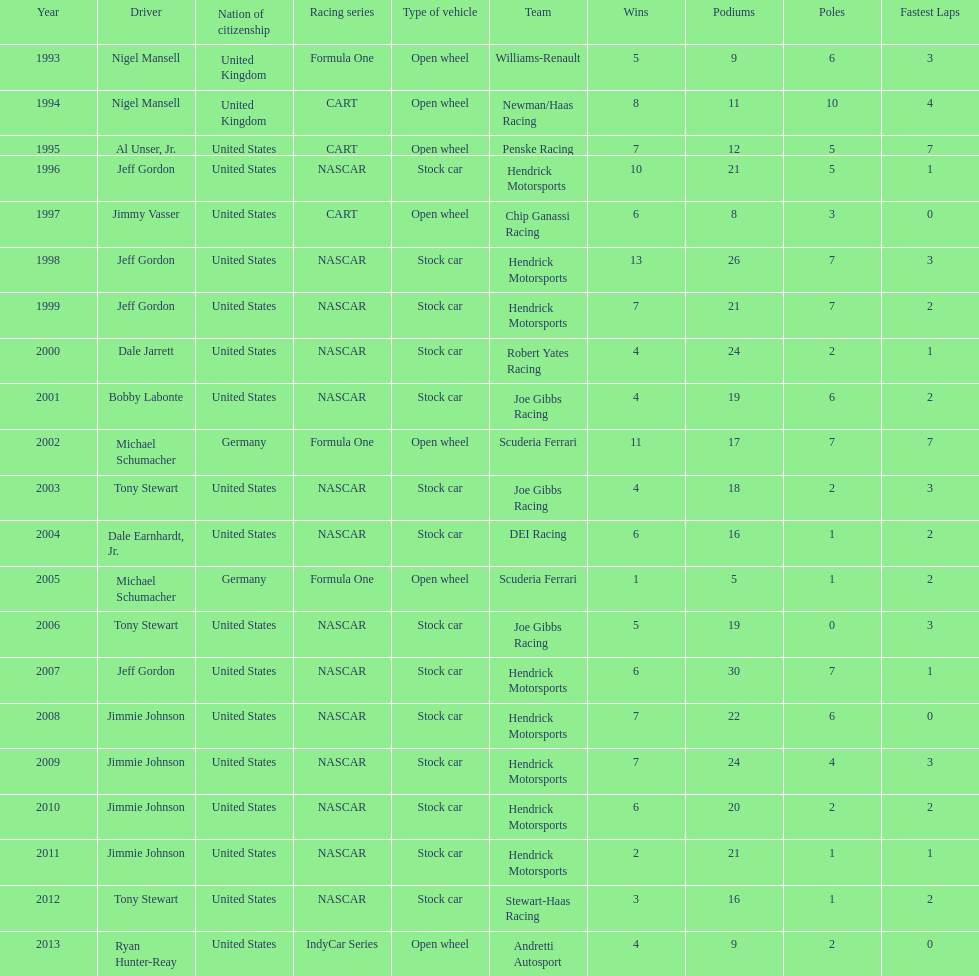How many occasions did jeff gordon achieve the award? 4. 